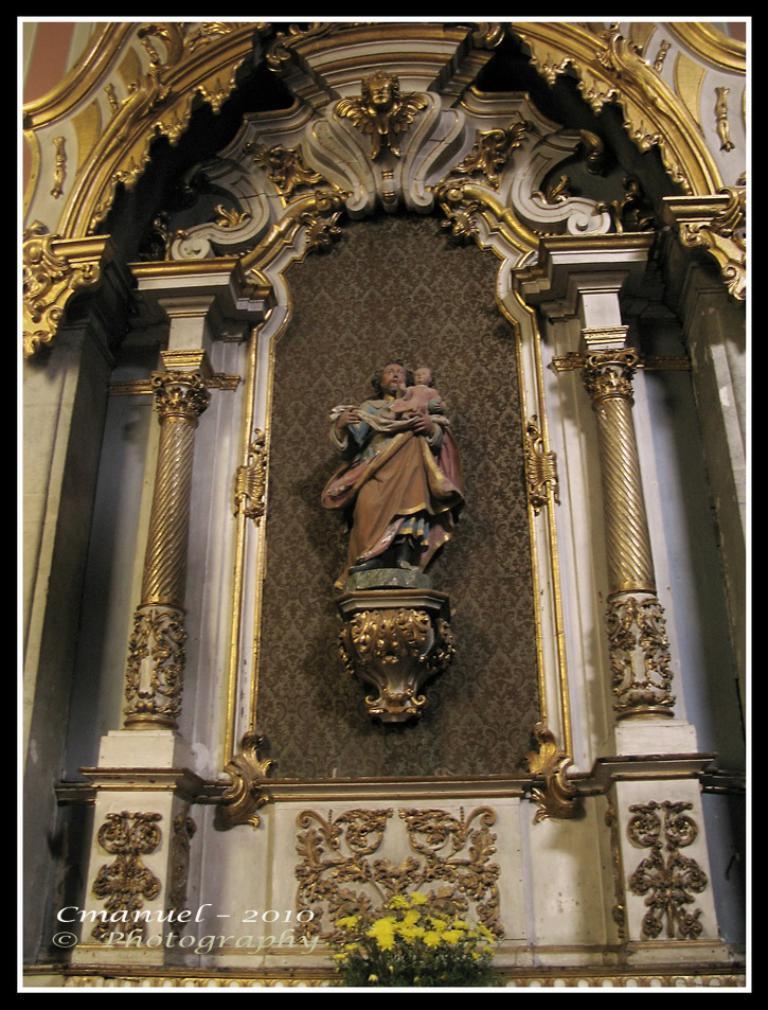In one or two sentences, can you explain what this image depicts? In the picture I can see a sculptures and designs wall, in front we can see some flowers. 